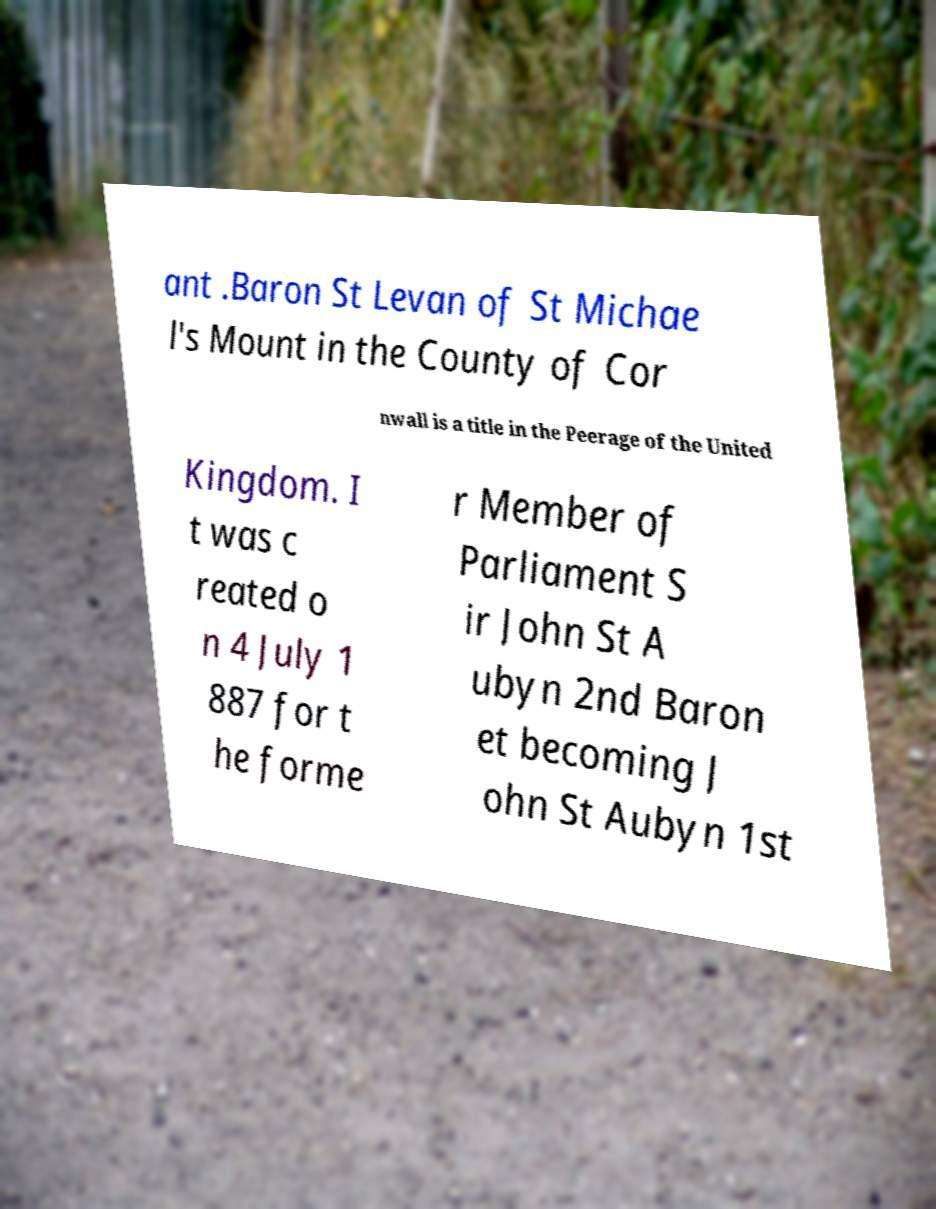Could you assist in decoding the text presented in this image and type it out clearly? ant .Baron St Levan of St Michae l's Mount in the County of Cor nwall is a title in the Peerage of the United Kingdom. I t was c reated o n 4 July 1 887 for t he forme r Member of Parliament S ir John St A ubyn 2nd Baron et becoming J ohn St Aubyn 1st 